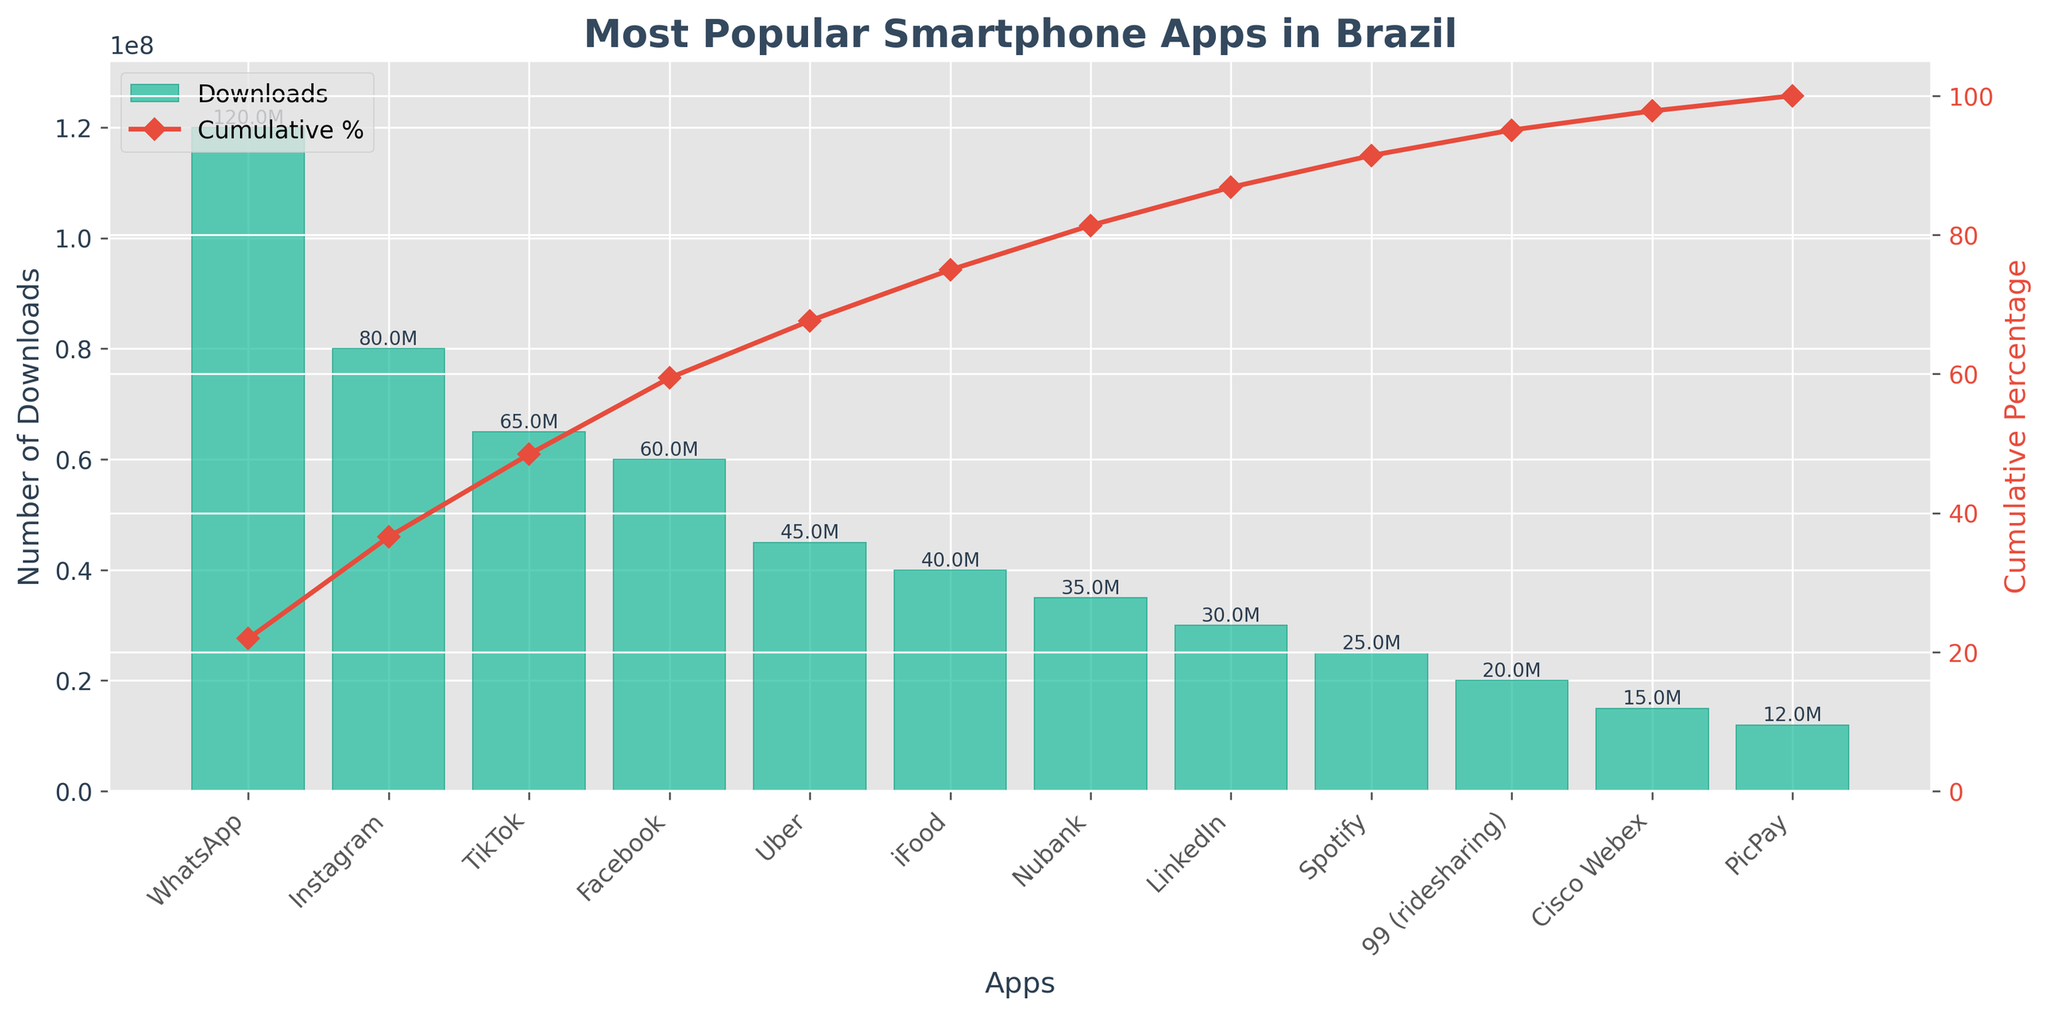What is the title of the figure? The title is located at the top of the chart and is visually distinct as it's typically larger and bold.
Answer: Most Popular Smartphone Apps in Brazil Which app has the highest number of downloads? The app with the tallest bar corresponds to the highest number of downloads.
Answer: WhatsApp What is the cumulative percentage of downloads for Instagram and WhatsApp combined? First, sum the downloads of Instagram (80M) and WhatsApp (120M) which equals 200M. Then, find the cumulative percentage up to and including Instagram from the line plot, which is close to 50%.
Answer: Around 50% Which three apps have the lowest number of downloads? Identify the bars with the three shortest heights.
Answer: PicPay, Cisco Webex, and 99 (ridesharing) What percentage of total downloads is represented by TikTok alone? Find the height of the TikTok bar (65M) and divide it by the total downloads, then multiply by 100%. 65M/460M * 100% ≈ 14.13%
Answer: Around 14.13% Which app's cumulative downloads reach or just surpass 70% of total downloads? From the cumulative percentage line, identify the app where the cumulative percentage crosses 70%.
Answer: Facebook Compare the number of downloads of iFood and Uber. Which one has more and by how much? Compare the heights of the bars of iFood (40M) and Uber (45M) and calculate the difference. 45M - 40M = 5M
Answer: Uber, 5M more How many apps have more than 50 million downloads? Count the number of bars with heights exceeding the 50M mark.
Answer: Four apps What is the approximate cumulative percentage after including the top 5 apps? Inspect the cumulative percentage line after the 5th bar (Uber) to find where it lands on the y-axis.
Answer: Around 89% What is the color of the line representing the cumulative percentage? Observe the color of the line that tracks the cumulative percentage.
Answer: Red 